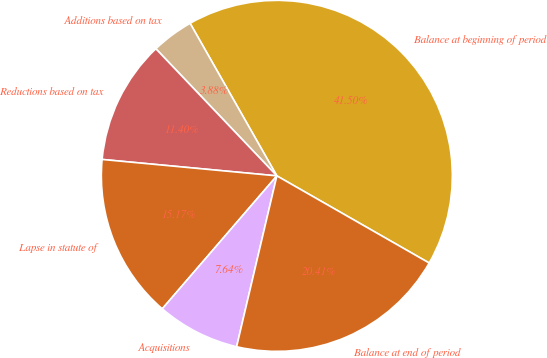Convert chart. <chart><loc_0><loc_0><loc_500><loc_500><pie_chart><fcel>Balance at beginning of period<fcel>Additions based on tax<fcel>Reductions based on tax<fcel>Lapse in statute of<fcel>Acquisitions<fcel>Balance at end of period<nl><fcel>41.5%<fcel>3.88%<fcel>11.4%<fcel>15.17%<fcel>7.64%<fcel>20.41%<nl></chart> 